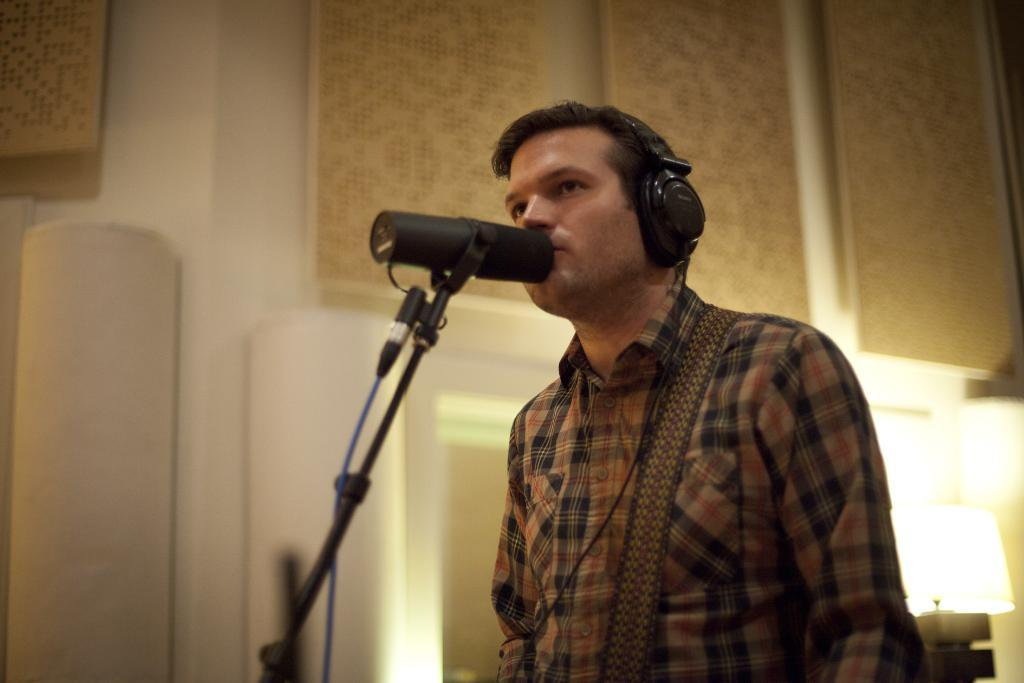Who or what is present in the image? There is a person in the image. What is the person wearing? The person is wearing headsets. What object is in front of the person? There is a microphone stand in front of the person. Can you describe any other objects in the image? There is a lamp in the bottom right corner of the image. What can be seen in the background of the image? There is a wall in the background of the image. How many trucks are parked behind the person in the image? There are no trucks visible in the image. 